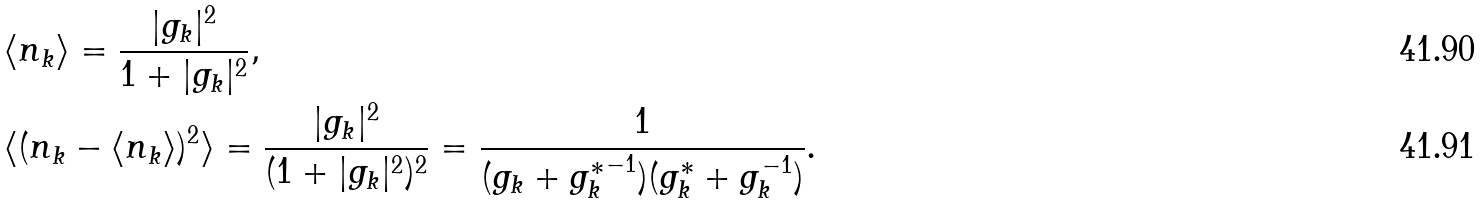Convert formula to latex. <formula><loc_0><loc_0><loc_500><loc_500>& \langle n _ { k } \rangle = \frac { | g _ { k } | ^ { 2 } } { 1 + | g _ { k } | ^ { 2 } } , \\ & \langle ( n _ { k } - \langle { n _ { k } } \rangle ) ^ { 2 } \rangle = \frac { | g _ { k } | ^ { 2 } } { ( 1 + | g _ { k } | ^ { 2 } ) ^ { 2 } } = \frac { 1 } { ( g _ { k } + { g _ { k } ^ { * } } ^ { - 1 } ) ( g _ { k } ^ { * } + g _ { k } ^ { - 1 } ) } .</formula> 